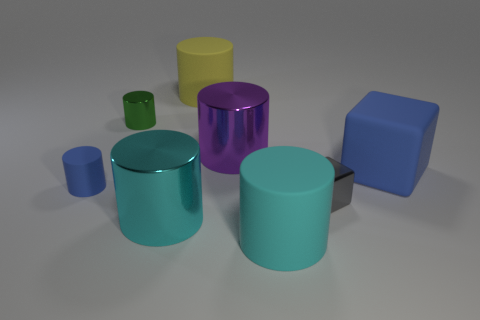Are there any other things that are the same shape as the gray metal thing? Yes, there are several items in the image that share a similar cylindrical shape to the gray metal object. For instance, the blue-green, teal, and purple objects all exhibit a cylindrical form, which is characterized by a circular base and straight parallel sides. 